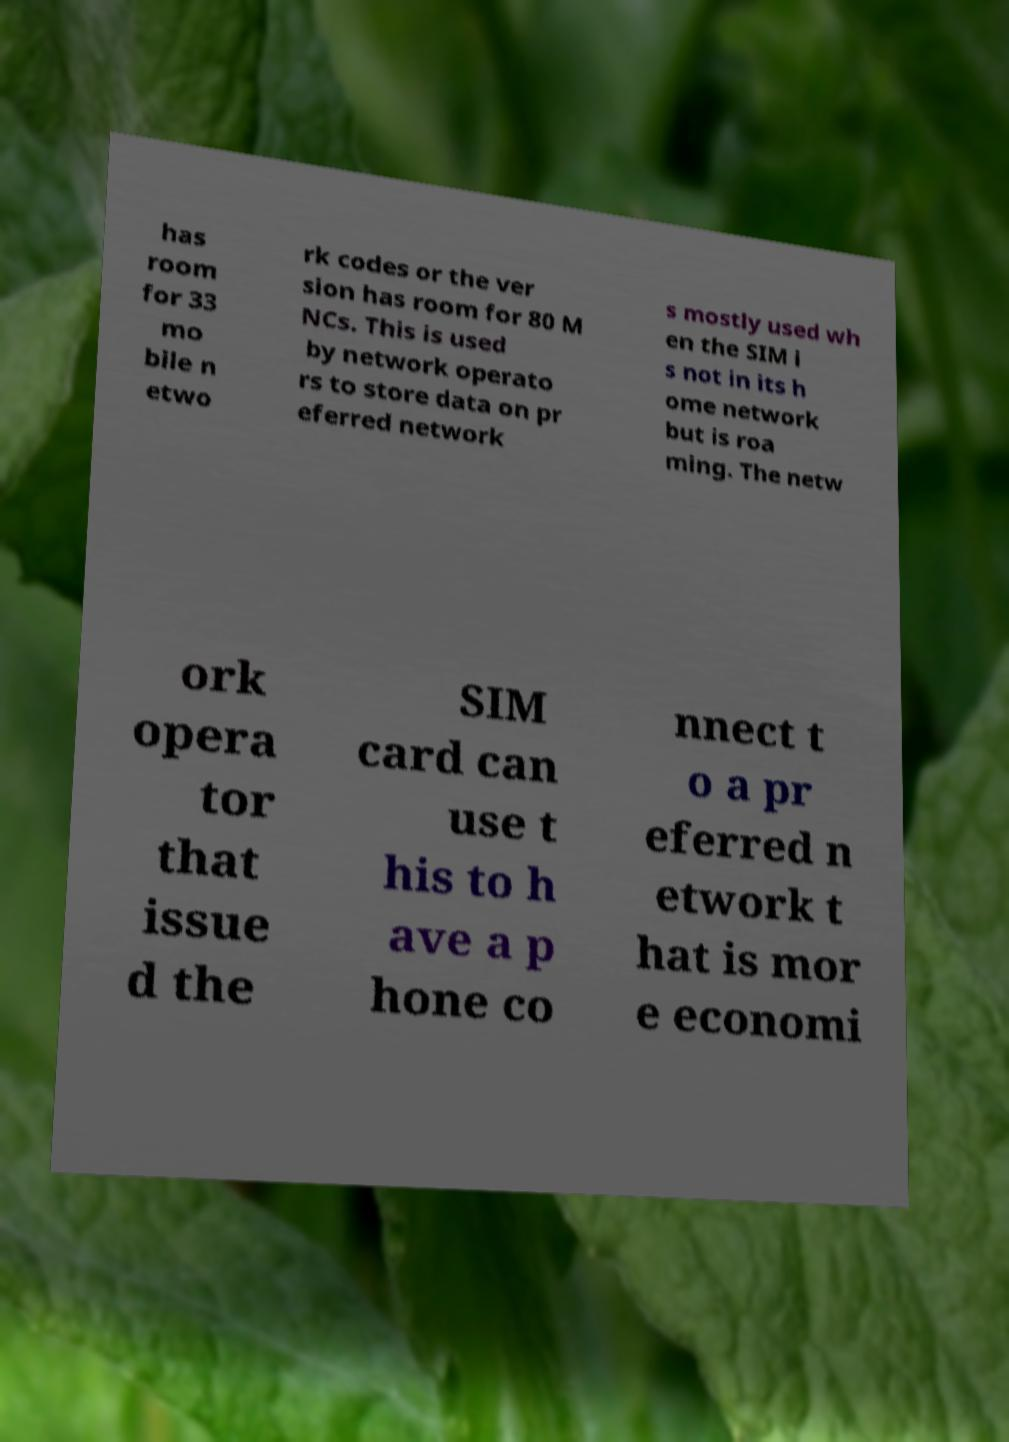Please identify and transcribe the text found in this image. has room for 33 mo bile n etwo rk codes or the ver sion has room for 80 M NCs. This is used by network operato rs to store data on pr eferred network s mostly used wh en the SIM i s not in its h ome network but is roa ming. The netw ork opera tor that issue d the SIM card can use t his to h ave a p hone co nnect t o a pr eferred n etwork t hat is mor e economi 